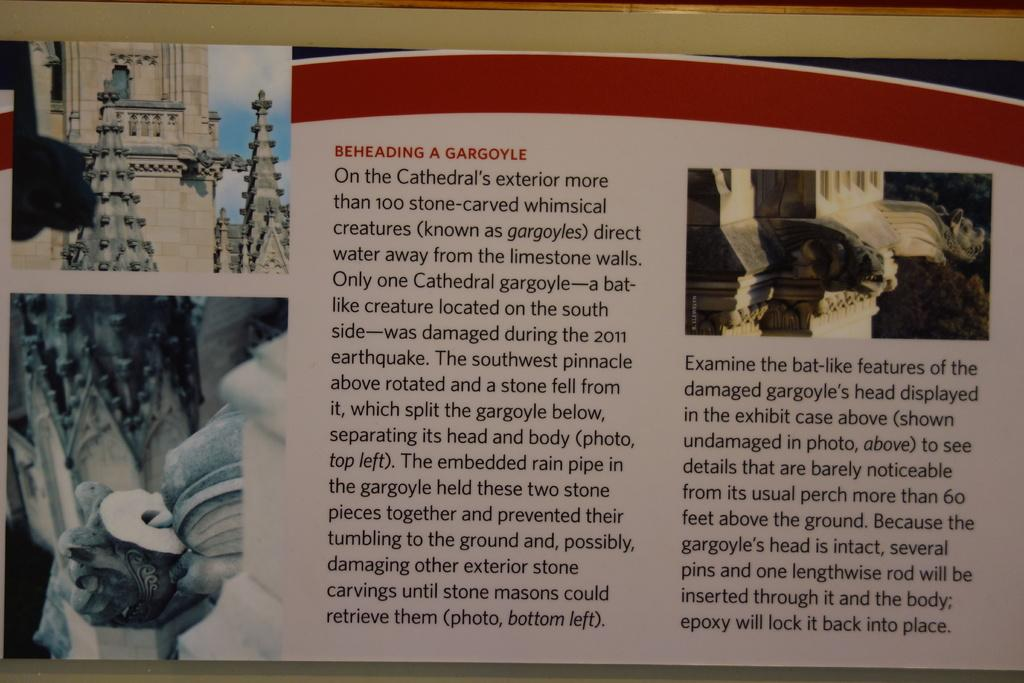<image>
Write a terse but informative summary of the picture. An article that is entitled Beheading a Gargoyle. 